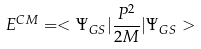Convert formula to latex. <formula><loc_0><loc_0><loc_500><loc_500>E ^ { C M } = < \Psi _ { G S } | \frac { { P } ^ { 2 } } { 2 M } | \Psi _ { G S } ></formula> 